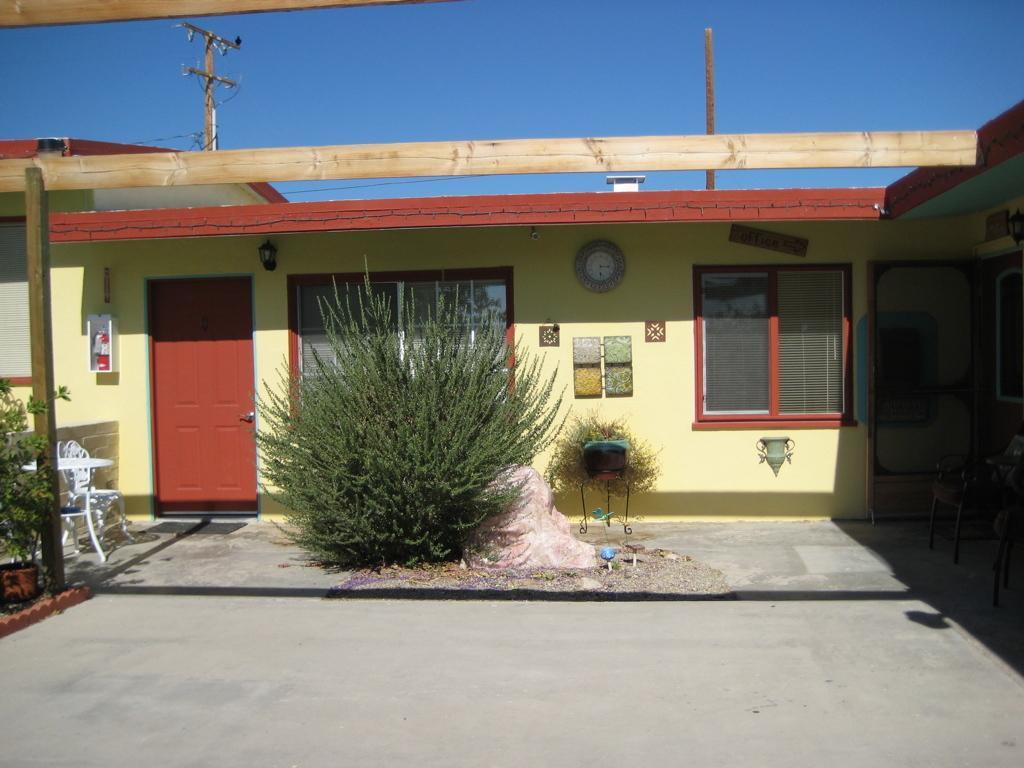Can you describe this image briefly? In this image I can see the ground, few trees which are green in color, a white colored chair and a house which is cream and brown in color. I can see few wooden logs, door which is brown in color and in the background I can see the sky. 